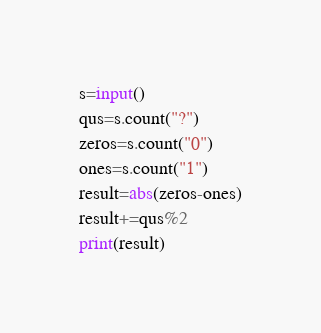Convert code to text. <code><loc_0><loc_0><loc_500><loc_500><_Python_>s=input()
qus=s.count("?")
zeros=s.count("0")
ones=s.count("1")
result=abs(zeros-ones)
result+=qus%2
print(result)</code> 